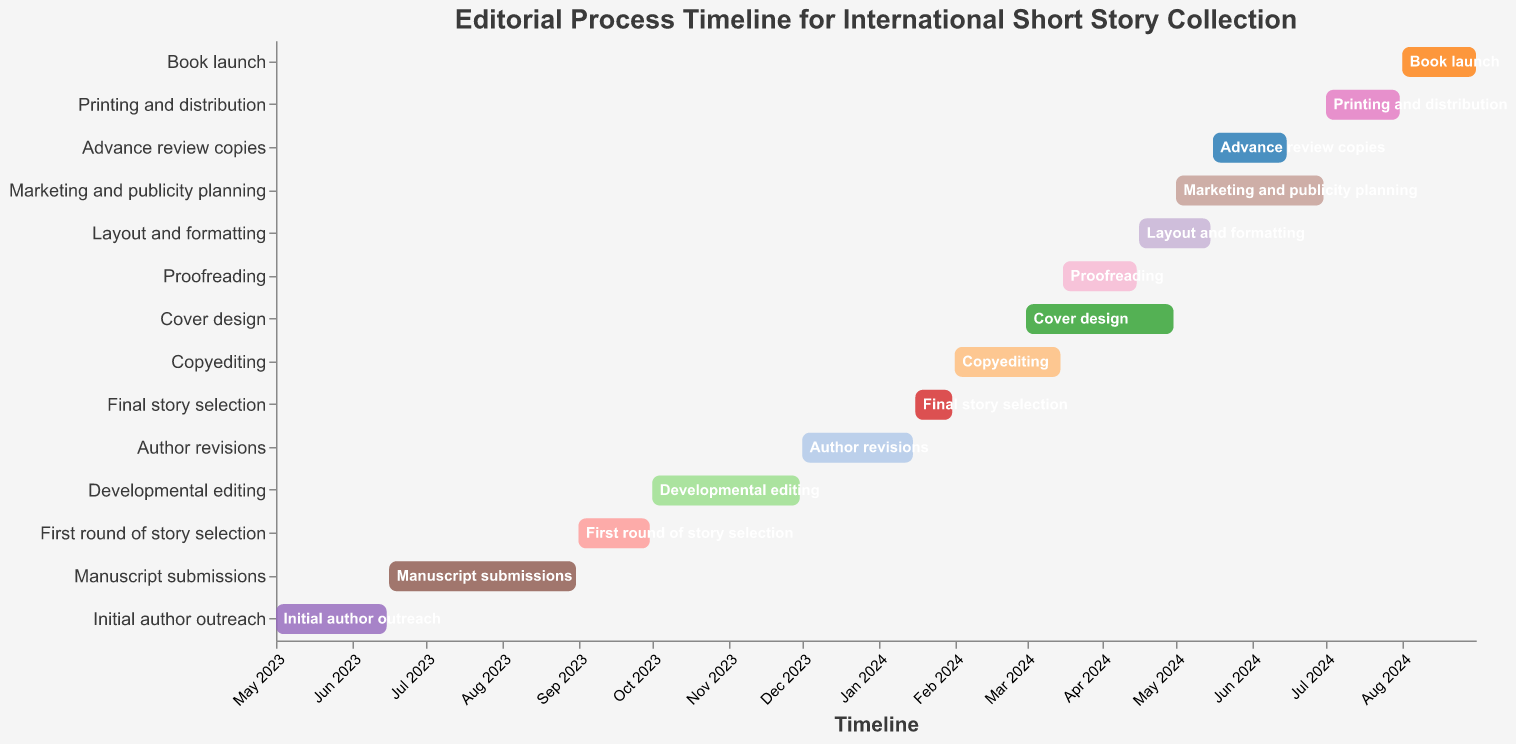What is the title of the Gantt Chart? The title is usually located at the top of the chart and provides a summary of the content.
Answer: Editorial Process Timeline for International Short Story Collection When does the Initial author outreach begin and end? Look at the Gantt bar labeled "Initial author outreach"; the start and end dates are displayed on the x-axis.
Answer: Begins on May 1, 2023, and ends on June 15, 2023 How long is the Manuscript submissions phase? Locate the bar labeled "Manuscript submissions" and calculate the duration by finding the difference between the start and end dates.
Answer: 77 days Which phases overlap with the Proofreading phase? Identify the timeframe for "Proofreading" and observe which other task bars intersect this period.
Answer: Cover design, Marketing and publicity planning Which task has the shortest duration, and what is its duration? Scan through each task's start and end dates, then compute the duration for each. Identify the task with the shortest duration.
Answer: Final story selection, 16 days How many tasks take place entirely within the year 2024? Count the tasks that both start and end in the year 2024.
Answer: 8 tasks What phase directly follows Author revisions? Check the end date of "Author revisions" and find the task that begins right after or overlaps.
Answer: Final story selection Compare the duration of Developmental editing and Copyediting. Which one is longer and by how many days? Calculate the duration for both "Developmental editing" and "Copyediting" by subtracting their start dates from their end dates, then compare the two durations.
Answer: Developmental editing is longer by 15 days During which months does the Marketing and publicity planning phase occur? Look at the bar for "Marketing and publicity planning" and note the months covered between the start date and end date.
Answer: May 2024 to June 2024 What two activities are planned for the month of May 2024? Find the tasks that cover the month of May 2024 by checking the overlaps with this timeframe.
Answer: Layout and formatting, Advance review copies Does the Book launch phase overlap with any other task? If yes, specify which task. Observe the time frame for the "Book launch" and check for any task bars that overlap with it.
Answer: No, it does not overlap with any task 